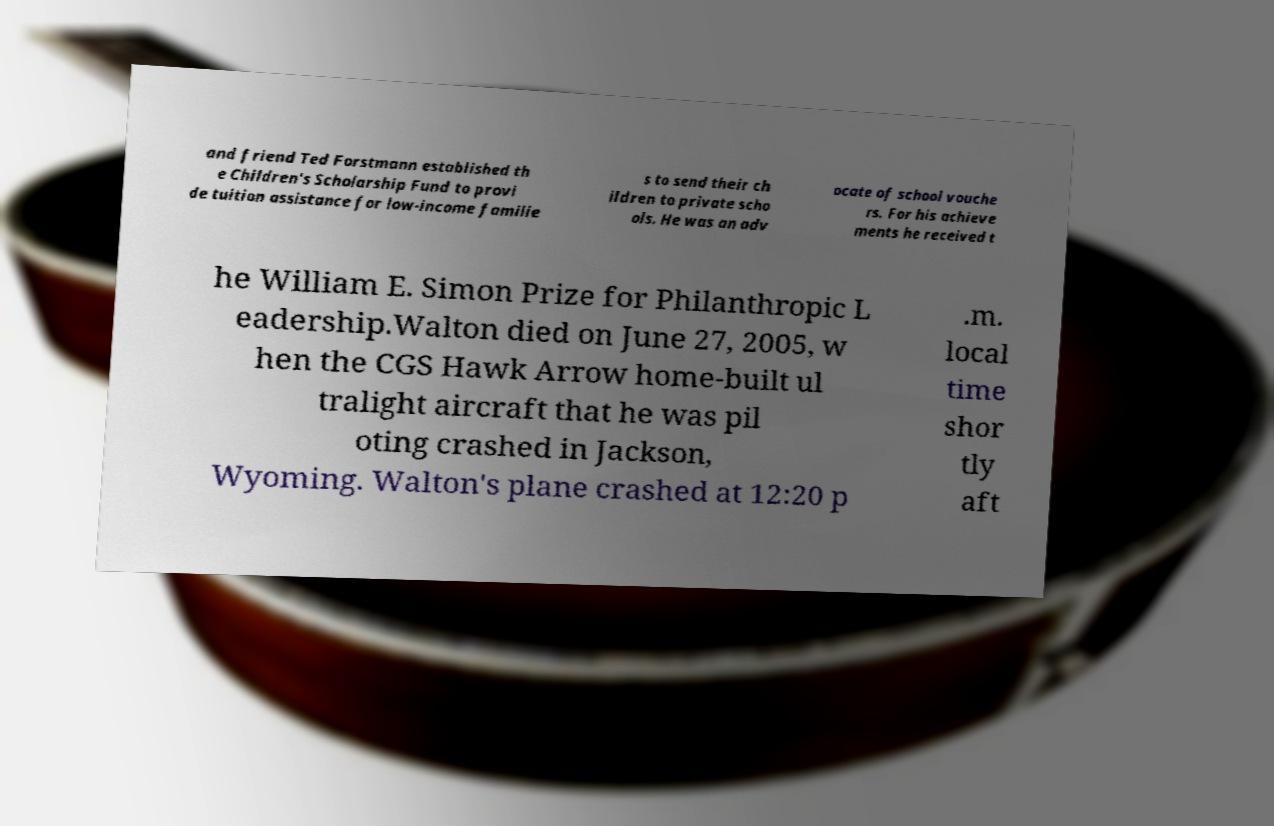What messages or text are displayed in this image? I need them in a readable, typed format. and friend Ted Forstmann established th e Children's Scholarship Fund to provi de tuition assistance for low-income familie s to send their ch ildren to private scho ols. He was an adv ocate of school vouche rs. For his achieve ments he received t he William E. Simon Prize for Philanthropic L eadership.Walton died on June 27, 2005, w hen the CGS Hawk Arrow home-built ul tralight aircraft that he was pil oting crashed in Jackson, Wyoming. Walton's plane crashed at 12:20 p .m. local time shor tly aft 